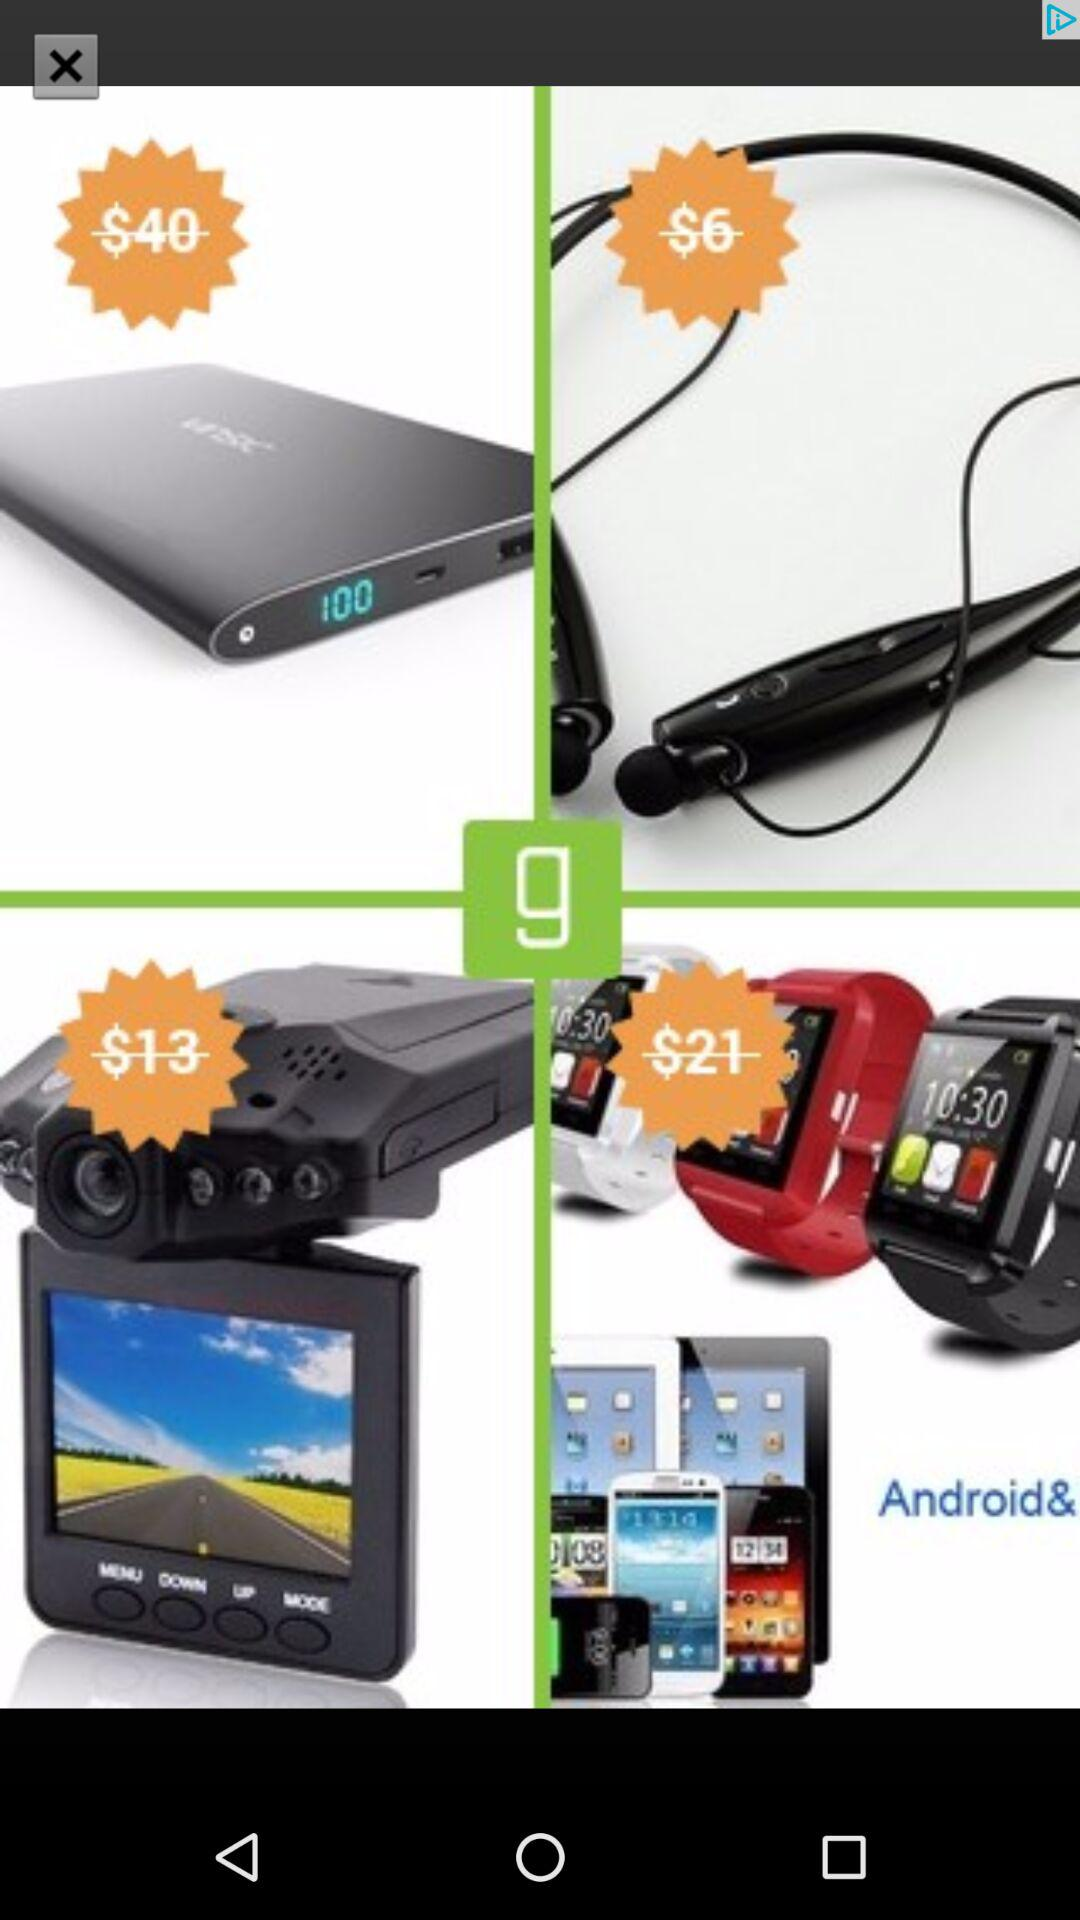How many items are in the cart?
Answer the question using a single word or phrase. 4 